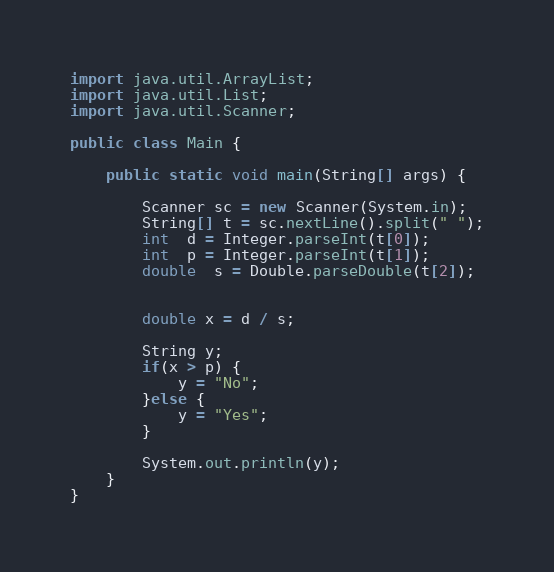<code> <loc_0><loc_0><loc_500><loc_500><_Java_>import java.util.ArrayList;
import java.util.List;
import java.util.Scanner;

public class Main {

	public static void main(String[] args) {

		Scanner sc = new Scanner(System.in);
		String[] t = sc.nextLine().split(" ");
		int  d = Integer.parseInt(t[0]);
		int  p = Integer.parseInt(t[1]);
		double  s = Double.parseDouble(t[2]);


		double x = d / s;

		String y;
		if(x > p) {
			y = "No";
		}else {
			y = "Yes";
		}

		System.out.println(y);
	}
}
</code> 